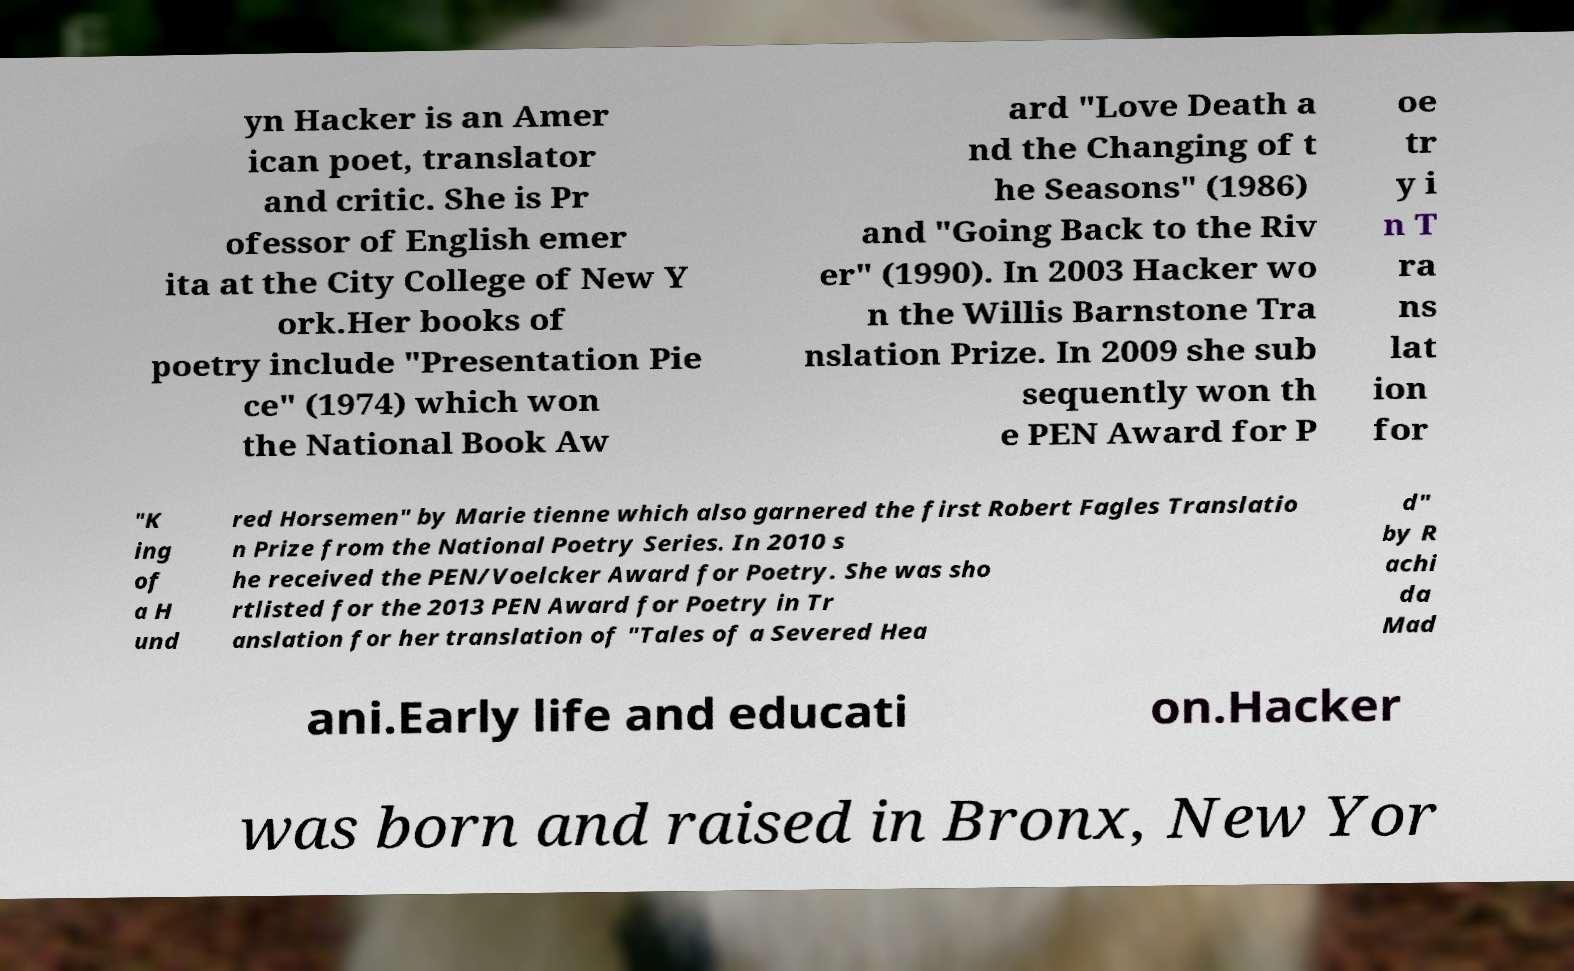For documentation purposes, I need the text within this image transcribed. Could you provide that? yn Hacker is an Amer ican poet, translator and critic. She is Pr ofessor of English emer ita at the City College of New Y ork.Her books of poetry include "Presentation Pie ce" (1974) which won the National Book Aw ard "Love Death a nd the Changing of t he Seasons" (1986) and "Going Back to the Riv er" (1990). In 2003 Hacker wo n the Willis Barnstone Tra nslation Prize. In 2009 she sub sequently won th e PEN Award for P oe tr y i n T ra ns lat ion for "K ing of a H und red Horsemen" by Marie tienne which also garnered the first Robert Fagles Translatio n Prize from the National Poetry Series. In 2010 s he received the PEN/Voelcker Award for Poetry. She was sho rtlisted for the 2013 PEN Award for Poetry in Tr anslation for her translation of "Tales of a Severed Hea d" by R achi da Mad ani.Early life and educati on.Hacker was born and raised in Bronx, New Yor 